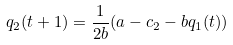Convert formula to latex. <formula><loc_0><loc_0><loc_500><loc_500>q _ { 2 } ( t + 1 ) = \frac { 1 } { 2 b } ( a - c _ { 2 } - b q _ { 1 } ( t ) ) \</formula> 